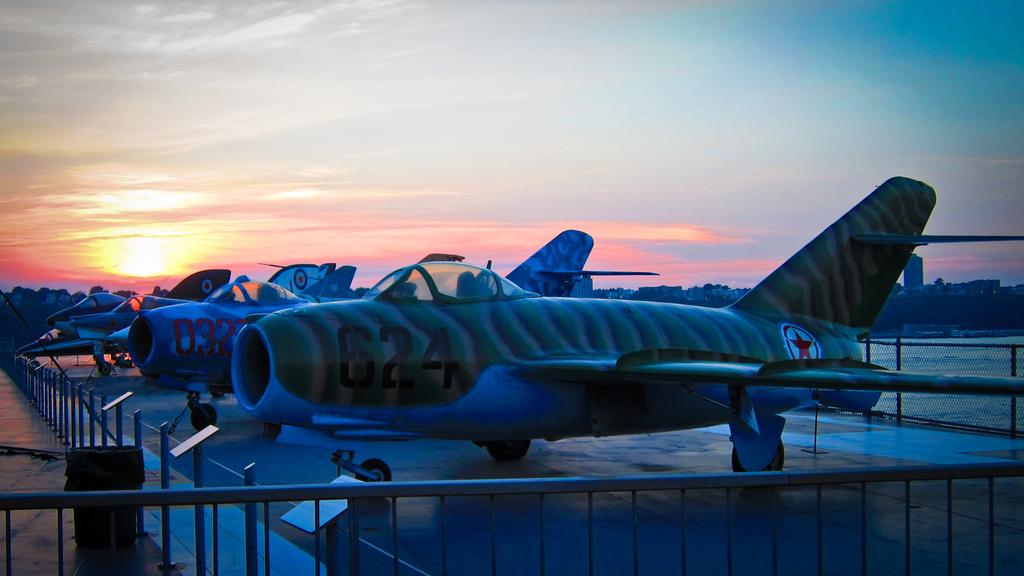Whats the numbers on the closest plane?
Ensure brevity in your answer.  624. What is the number on the second plane?
Your answer should be compact. 032. 